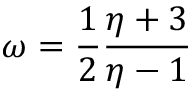<formula> <loc_0><loc_0><loc_500><loc_500>\omega = \frac { 1 } { 2 } \frac { \eta + 3 } { \eta - 1 }</formula> 